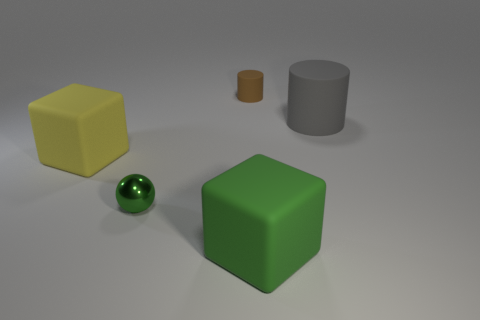Subtract all green cylinders. Subtract all red spheres. How many cylinders are left? 2 Add 4 small objects. How many objects exist? 9 Subtract all cubes. How many objects are left? 3 Subtract all gray things. Subtract all brown rubber objects. How many objects are left? 3 Add 1 blocks. How many blocks are left? 3 Add 1 big red rubber blocks. How many big red rubber blocks exist? 1 Subtract 1 gray cylinders. How many objects are left? 4 